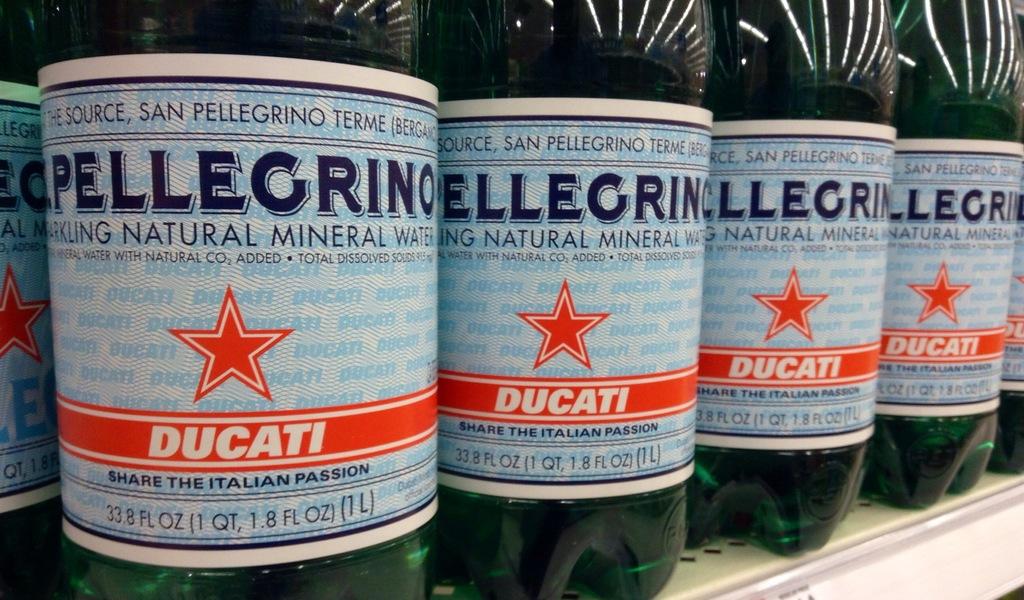Is the water natural?
Keep it short and to the point. Yes. What is the brand of the beverage written in the red area?
Your answer should be compact. Ducati. 